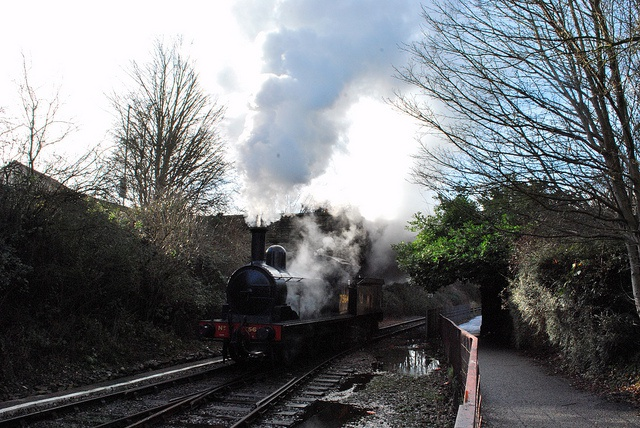Describe the objects in this image and their specific colors. I can see a train in white, black, gray, and darkgray tones in this image. 